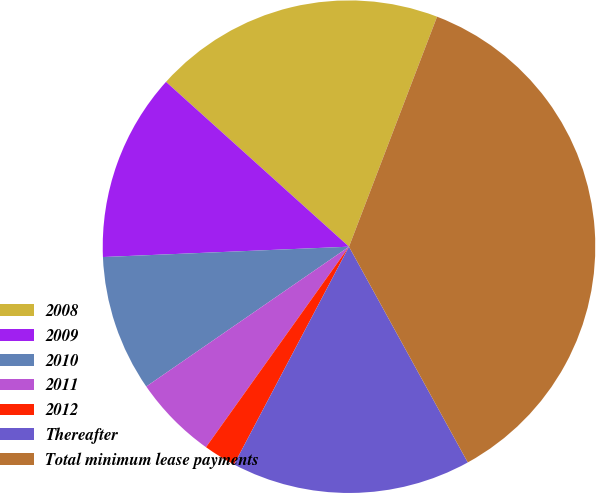Convert chart. <chart><loc_0><loc_0><loc_500><loc_500><pie_chart><fcel>2008<fcel>2009<fcel>2010<fcel>2011<fcel>2012<fcel>Thereafter<fcel>Total minimum lease payments<nl><fcel>19.15%<fcel>12.34%<fcel>8.94%<fcel>5.53%<fcel>2.13%<fcel>15.74%<fcel>36.17%<nl></chart> 